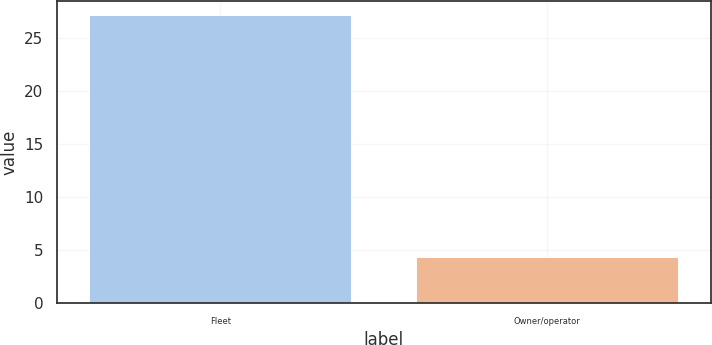<chart> <loc_0><loc_0><loc_500><loc_500><bar_chart><fcel>Fleet<fcel>Owner/operator<nl><fcel>27.2<fcel>4.4<nl></chart> 